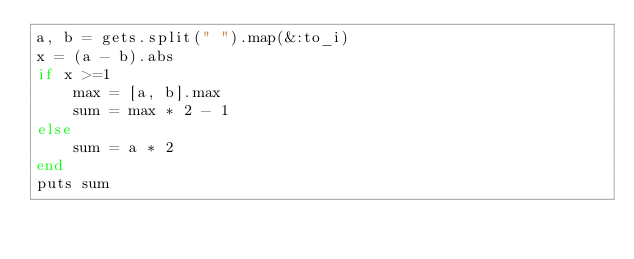Convert code to text. <code><loc_0><loc_0><loc_500><loc_500><_Ruby_>a, b = gets.split(" ").map(&:to_i)
x = (a - b).abs
if x >=1
    max = [a, b].max
    sum = max * 2 - 1
else
    sum = a * 2
end
puts sum
</code> 